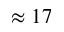Convert formula to latex. <formula><loc_0><loc_0><loc_500><loc_500>\approx 1 7</formula> 